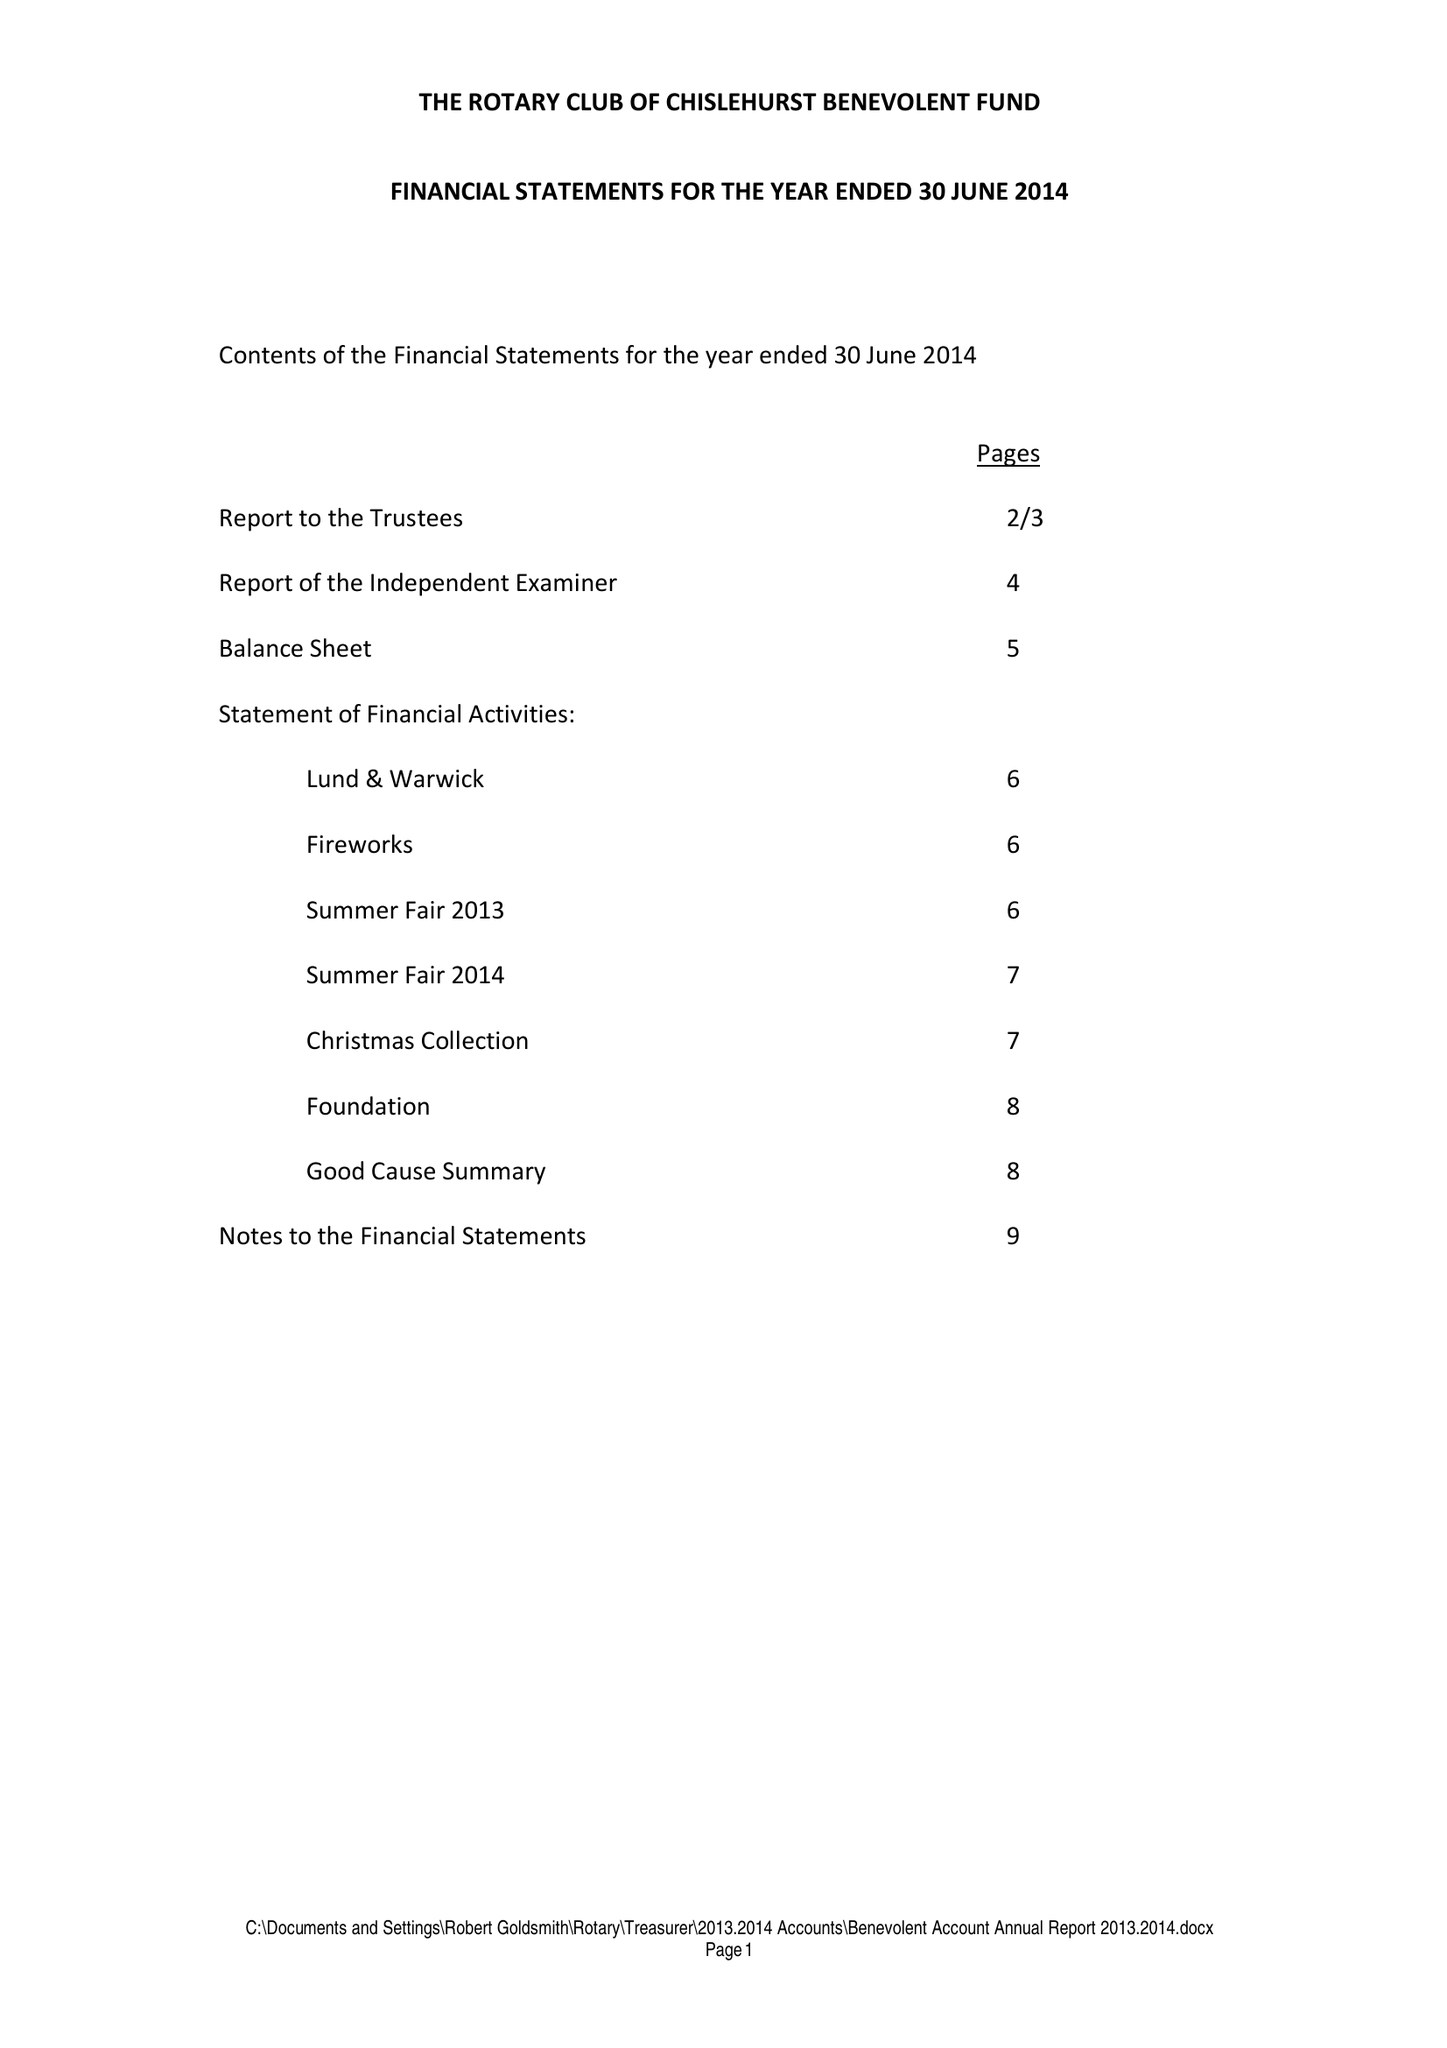What is the value for the address__street_line?
Answer the question using a single word or phrase. CHELSFIELD LANE 